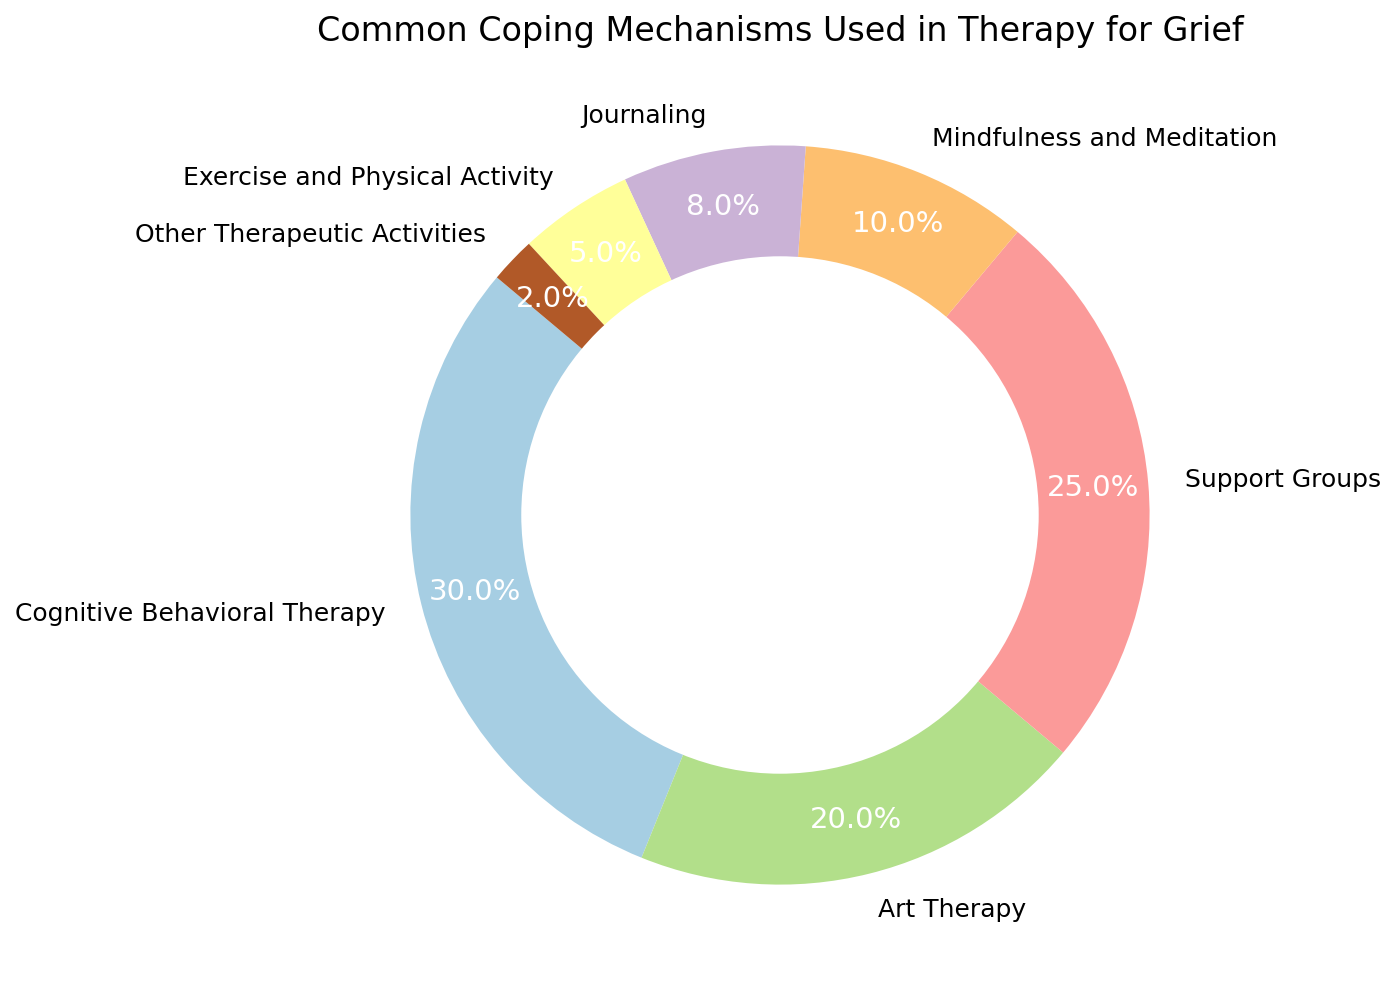What percentage of coping mechanisms involves physical activities like Exercise and Physical Activity? Locate the "Exercise and Physical Activity" segment on the pie chart, which is labeled with its percentage.
Answer: 5% Which coping mechanism has more representation: Art Therapy or Support Groups? Compare the segments labeled "Art Therapy" and "Support Groups." Art Therapy is 20%, and Support Groups is 25%.
Answer: Support Groups How much larger is the Cognitive Behavioral Therapy segment compared to the Journaling segment? Identify the percentages of Cognitive Behavioral Therapy (30%) and Journaling (8%), then compute the difference: 30% - 8% = 22%.
Answer: 22% What is the total percentage of all coping mechanisms other than Cognitive Behavioral Therapy? Add the percentages of all segments except Cognitive Behavioral Therapy: (20% + 25% + 10% + 8% + 5% + 2%) = 70%.
Answer: 70% Is the segment for Mindfulness and Meditation larger than the segment for Journaling? Compare the segments of Mindfulness and Meditation (10%) and Journaling (8%).
Answer: Yes What is the combined percentage of the two smallest segments? Identify the two smallest segments, "Other Therapeutic Activities" (2%) and "Exercise and Physical Activity" (5%). Then add them: 2% + 5% = 7%.
Answer: 7% Which single coping mechanism constitutes the largest percentage of the chart? Identify which segment has the largest percentage. Cognitive Behavioral Therapy is 30%, the largest segment.
Answer: Cognitive Behavioral Therapy By how many percentage points does Support Groups exceed Mindfulness and Meditation? Compare the percentages of Support Groups (25%) and Mindfulness and Meditation (10%). Calculate the difference: 25% - 10% = 15%.
Answer: 15% What proportion of the pie chart consists of either Art Therapy or Support Groups? Add the percentages of Art Therapy (20%) and Support Groups (25%): 20% + 25% = 45%.
Answer: 45% 